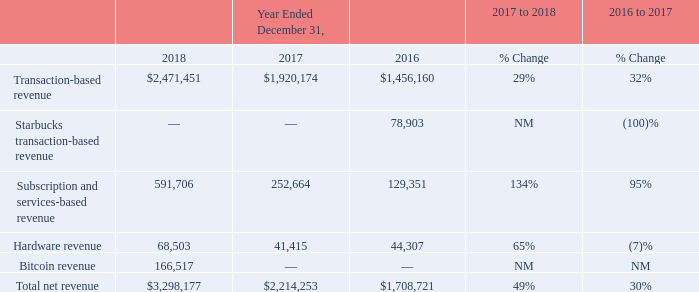Results of Operations
Revenue (in thousands, except for percentages)
Comparison of Years Ended December 31, 2018 and 2017
Total net revenue for the year ended December 31, 2018, increased by $1,083.9 million, or 49%, compared to the year ended December 31, 2017.
Transaction-based revenue for the year ended December 31, 2018, increased by $551.3 million, or 29%, compared to the year ended December 31, 2017. This increase was attributable to the growth in GPV processed of $19.3 billion, or 30%, to $84.7 billion from $65.3 billion. We continued to benefit from growth in processed volumes from our existing sellers, in addition to meaningful contributions from new sellers. Additionally, GPV from larger sellers, which we define as all sellers that generate more than $125,000 in annualized GPV, represented 51% of our GPV in the fourth quarter of 2018, an increase from 47% in the fourth quarter of 2017. We continued to see ongoing success with attracting and enabling large seller growth, which we believe will help drive strong GPV growth as we scale.
Subscription and services-based revenue for the year ended December 31, 2018 increased by $339.0 million, or 134%, compared to the year ended December 31, 2017. Growth was driven primarily by Instant Deposit, Caviar, Cash Card, and Square Capital, as well as acquisitions completed in the second quarter. Subscription and services-based revenue grew to 18% of total net revenue in the year ended December 31, 2018, up from 11% in the year ended December 31, 2017.
Hardware revenue for the year ended December 31, 2018, increased by $27.1 million, or 65%, compared to the year ended December 31, 2017. The increase primarily reflects growth in shipments of Square Register following its launch in the fourth quarter of 2017 and, to a lesser extent, the launch of Square Terminal during the fourth quarter of 2018. The increase was also driven by continued growth in sales of our contactless and chip readers, as well as growth in sales of our Square Stand and third-party peripherals driven primarily by new features and product offerings. Additionally, the adoption of ASC 606 resulted in an increase of $5.9 million in hardware revenue for the year ended December 31, 2018 primarily related to the earlier revenue recognition of hardware sold through retail distribution channels and hardware installment sales, which were previously recorded upon sell through to the end user customer.
Bitcoin revenue for the year ended December 31, 2018, increased by $166.5 million compared to the year ended December 31, 2017. During the fourth quarter of 2017, we started offering our Cash App customers the ability to purchase bitcoin from us. Bitcoin revenue comprises the total sale amount we receive from bitcoin sales to customers and is recorded upon transfer of bitcoin to the customer’s account. The sale amount generally includes a small margin added to the price we pay to purchase bitcoin and accordingly, the amount of bitcoin revenue will fluctuate depending on the volatility of market bitcoin prices and customer demand.
What was the cause of the increase in transaction-based revenue from 2017 to 2018? The growth in gpv processed of $19.3 billion, or 30%, to $84.7 billion from $65.3 billion. What was the cause of the increase in Subscription and services-based revenue from 2017 to 2018? Instant deposit, caviar, cash card, and square capital, as well as acquisitions completed in the second quarter. How much did bitcoin revenue increase from 2017 to 2018? $166.5 million. Which period has the larger percentage change in total net revenue? From ROW8 COL6 and COL7 find the larger number and the corresponding period
Answer: 2017 to 2018. What is the percentage amount of Bitcoin revenue among the total net revenue in 2018?
Answer scale should be: percent. 166,517 / 3,298,177 
Answer: 5.05. What is the average hardware revenue from 2016 to 2018?
Answer scale should be: thousand. (44,307 + 41,415 + 68,503) / 3 
Answer: 51408.33. 